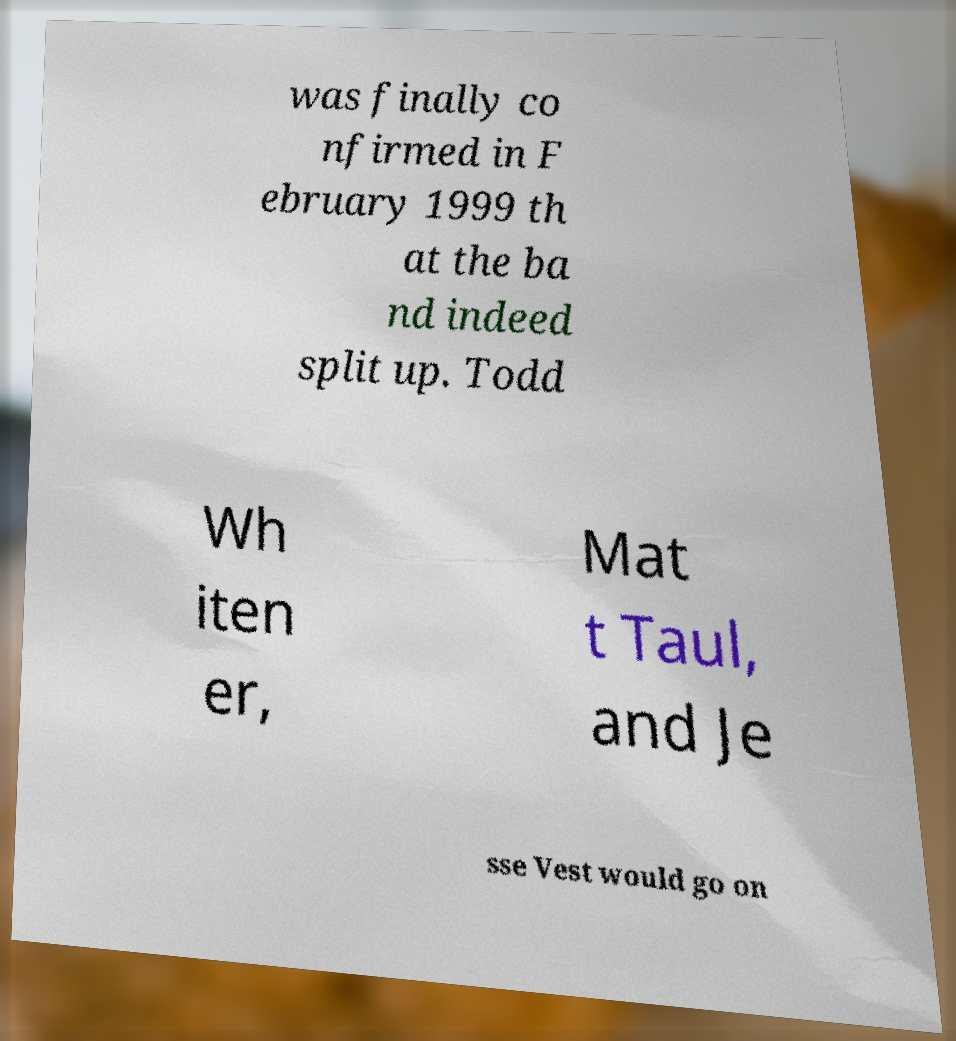Could you assist in decoding the text presented in this image and type it out clearly? was finally co nfirmed in F ebruary 1999 th at the ba nd indeed split up. Todd Wh iten er, Mat t Taul, and Je sse Vest would go on 